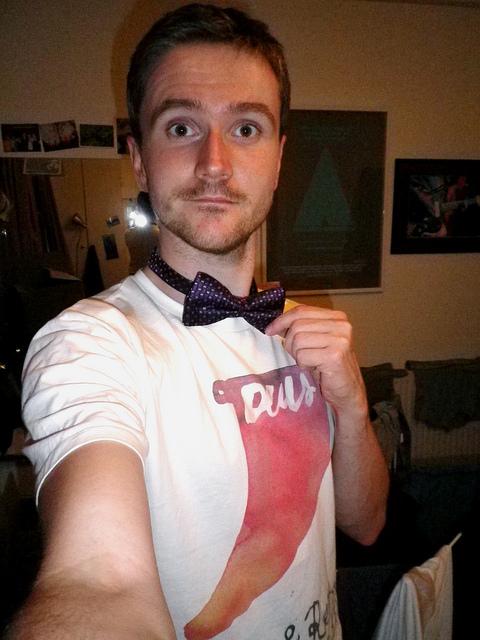Is this man dressed for a formal occasion?
Keep it brief. No. What kind of shirt is this person wearing?
Be succinct. T-shirt. What style of shirt is he wearing?
Short answer required. T-shirt. Is this a selfie pic?
Be succinct. Yes. What is on the man's neck?
Give a very brief answer. Bow tie. 